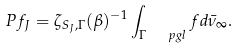<formula> <loc_0><loc_0><loc_500><loc_500>P f _ { J } = \zeta _ { S _ { J } , \Gamma } ( \beta ) ^ { - 1 } \int _ { \Gamma \ \ p g l } f d \bar { \nu } _ { \infty } .</formula> 